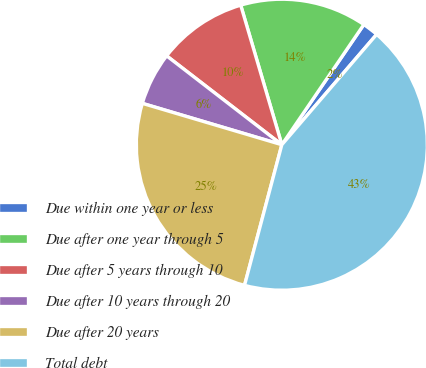Convert chart. <chart><loc_0><loc_0><loc_500><loc_500><pie_chart><fcel>Due within one year or less<fcel>Due after one year through 5<fcel>Due after 5 years through 10<fcel>Due after 10 years through 20<fcel>Due after 20 years<fcel>Total debt<nl><fcel>1.77%<fcel>14.09%<fcel>9.98%<fcel>5.87%<fcel>25.46%<fcel>42.83%<nl></chart> 